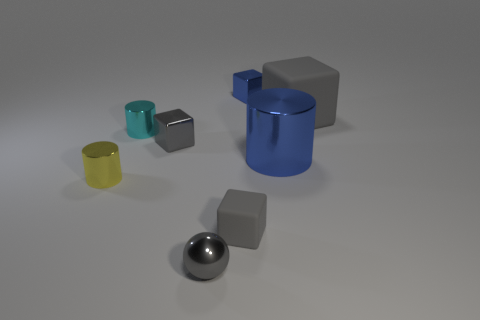What number of tiny things are the same color as the large matte cube?
Offer a very short reply. 3. What size is the matte cube that is to the right of the tiny block that is behind the cyan shiny thing?
Your answer should be compact. Large. The yellow thing has what shape?
Provide a succinct answer. Cylinder. There is a blue block that is right of the small yellow cylinder; what is its material?
Keep it short and to the point. Metal. What is the color of the tiny thing that is behind the gray matte block that is to the right of the small metallic thing on the right side of the gray sphere?
Your answer should be compact. Blue. What is the color of the rubber object that is the same size as the yellow metal thing?
Offer a very short reply. Gray. What number of metal objects are either big gray cylinders or small gray objects?
Provide a short and direct response. 2. There is a ball that is made of the same material as the big cylinder; what color is it?
Your response must be concise. Gray. The object that is behind the large thing that is to the right of the blue metallic cylinder is made of what material?
Provide a succinct answer. Metal. What number of objects are metallic cylinders that are to the right of the yellow metallic thing or objects behind the gray metal ball?
Keep it short and to the point. 7. 